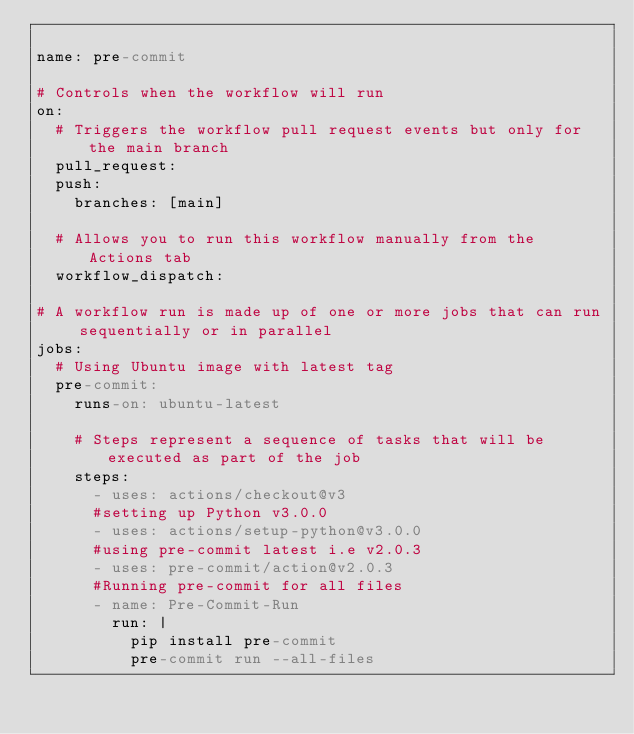Convert code to text. <code><loc_0><loc_0><loc_500><loc_500><_YAML_>
name: pre-commit

# Controls when the workflow will run
on:
  # Triggers the workflow pull request events but only for the main branch
  pull_request:
  push:
    branches: [main]

  # Allows you to run this workflow manually from the Actions tab
  workflow_dispatch:

# A workflow run is made up of one or more jobs that can run sequentially or in parallel
jobs:
  # Using Ubuntu image with latest tag
  pre-commit:
    runs-on: ubuntu-latest

    # Steps represent a sequence of tasks that will be executed as part of the job
    steps:
      - uses: actions/checkout@v3
      #setting up Python v3.0.0
      - uses: actions/setup-python@v3.0.0
      #using pre-commit latest i.e v2.0.3
      - uses: pre-commit/action@v2.0.3
      #Running pre-commit for all files
      - name: Pre-Commit-Run
        run: |
          pip install pre-commit
          pre-commit run --all-files
</code> 